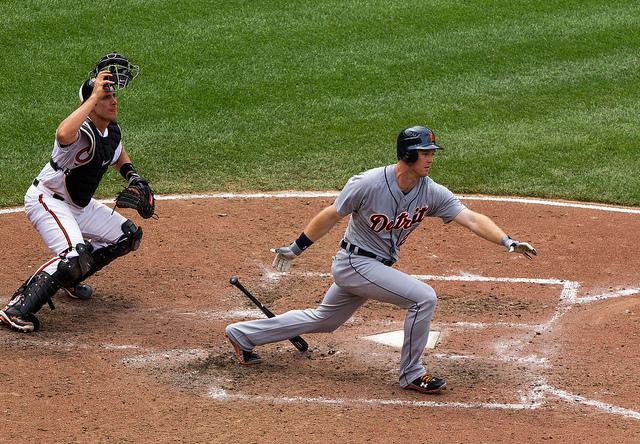What team does the man in gray play for?
Concise answer only. Detroit. Are both players wearing helmets?
Give a very brief answer. No. What sport is being played?
Be succinct. Baseball. 